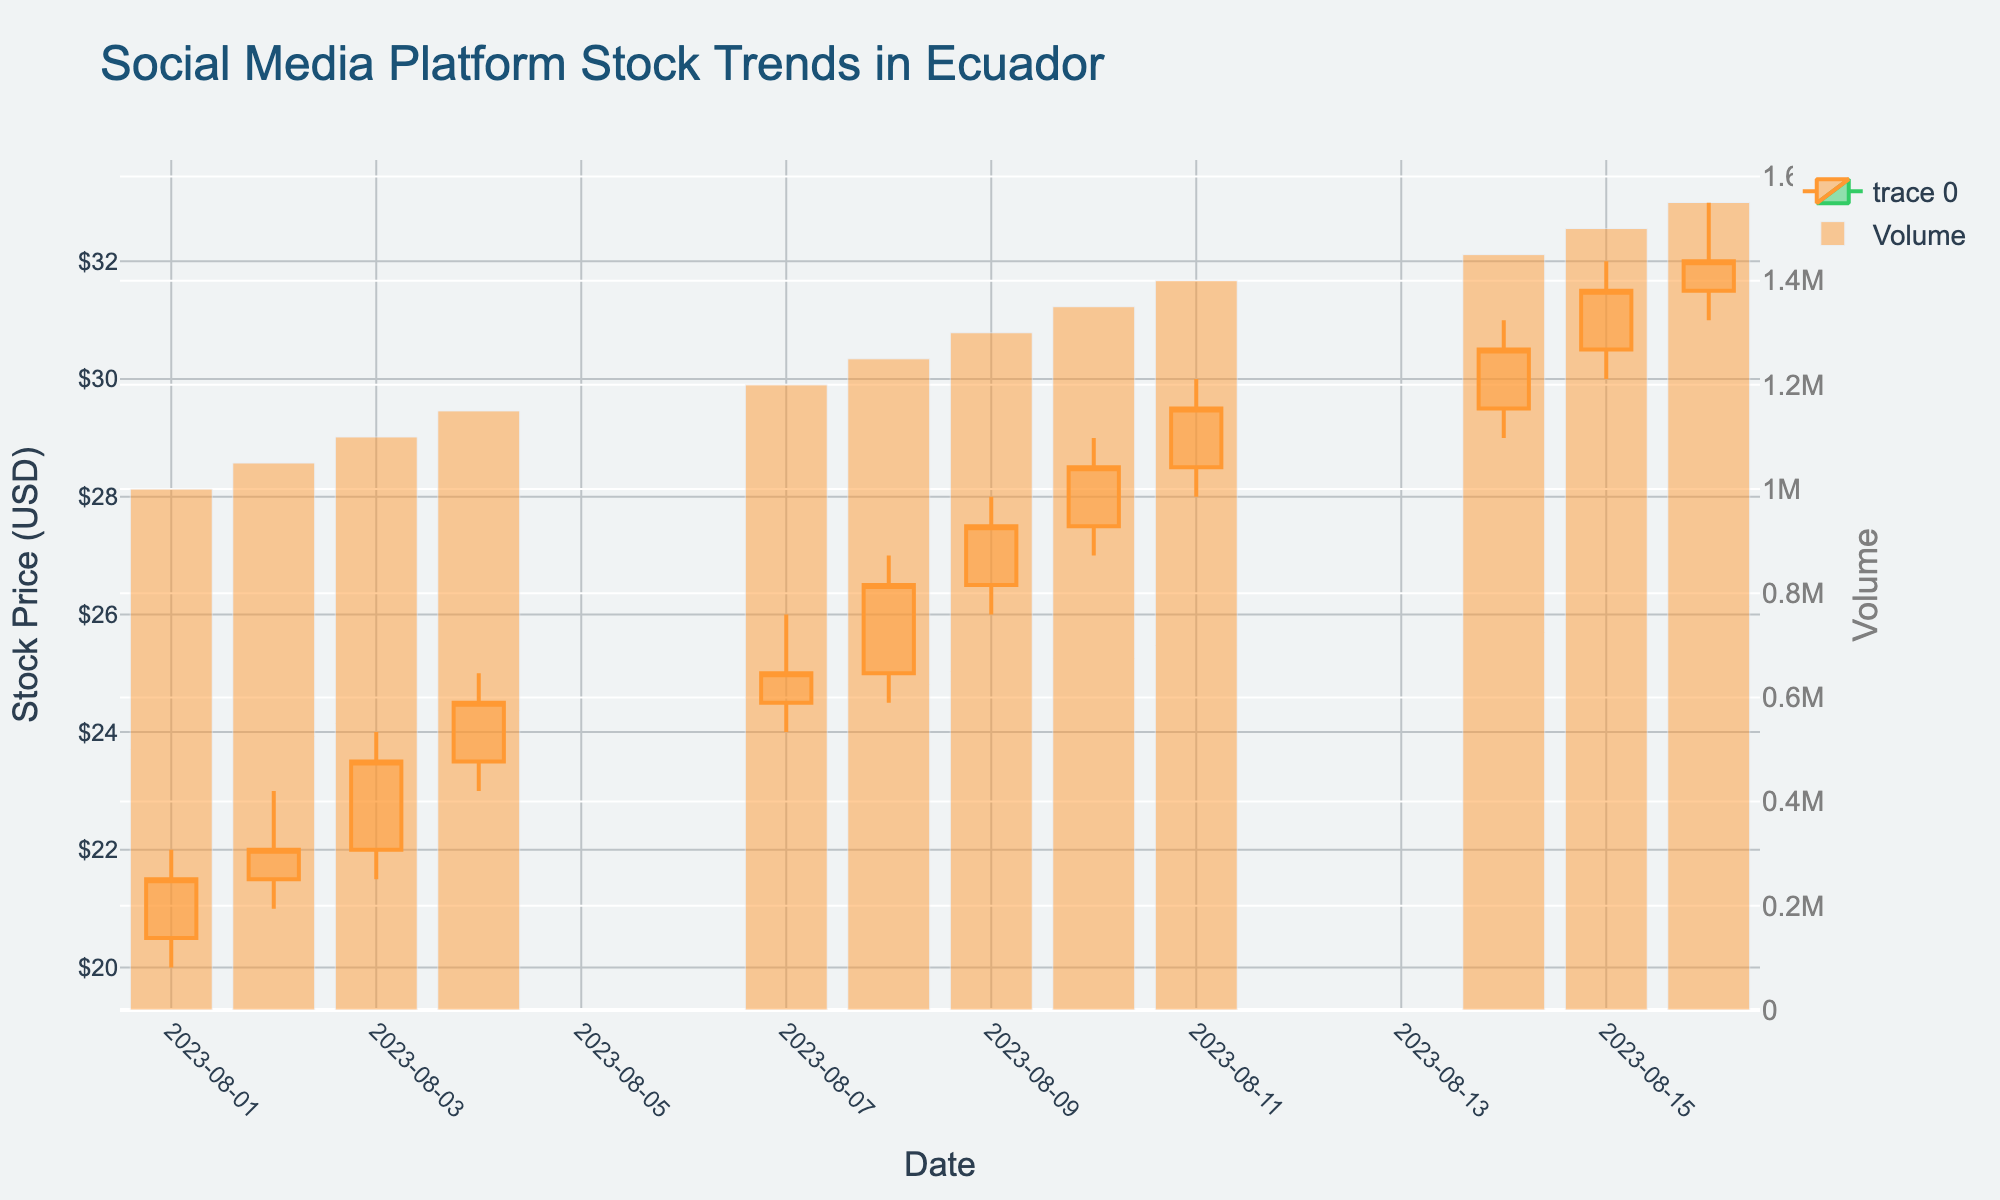What's the title of the chart? The title of the chart is displayed at the top of the figure. It reads "Social Media Platform Stock Trends in Ecuador".
Answer: Social Media Platform Stock Trends in Ecuador How does the stock price trend over the given period? By observing the candlestick chart, you can see that the stock price generally rises from August 1st, 2023 to August 16th, 2023. Each candlestick primarily shows a higher closing price compared to the previous day.
Answer: Upward trend What is the highest stock price reached during this period? The highest stock price can be identified by looking at the highest point on any of the candlesticks in the figure. On August 16th, the stock price reached a high of $33.00.
Answer: $33.00 Which day had the highest trading volume? The trading volume is represented by the bar chart below the candlesticks. The highest bar corresponds to August 16th, indicating the highest trading volume.
Answer: August 16 When did the stock price close at its highest point? The highest closing price is marked at the top end of the body of the candlesticks. On August 16, the stock closed at $32.00, which is the highest closing price during the period.
Answer: August 16 What was the opening stock price on August 8th, 2023? The opening price for August 8th can be found at the bottom of the body of the candlestick corresponding to that date. The opening price on this date was $25.00.
Answer: $25.00 How many trading days are represented in the chart? The number of trading days can be counted by the number of candlesticks on the chart. There are 11 candlesticks, representing 11 trading days.
Answer: 11 trading days What was the price range on August 4th, 2023? The price range can be calculated by finding the difference between the high and low prices shown by the ends of the candlestick's wick on August 4th. The range is $25.00 - $23.00 = $2.00.
Answer: $2.00 Between August 1st and August 7th, did the stock price increase or decrease? Comparing the closing price on August 1st ($21.50) with the closing price on August 7th ($25.00) indicates that the stock price increased during this period.
Answer: Increased Are there any days where the closing price is lower than the opening price? The candlestick's color indicates if the closing price is lower (green), indicating a decrease. All candlesticks are orange, meaning the closing price is higher every day.
Answer: No 